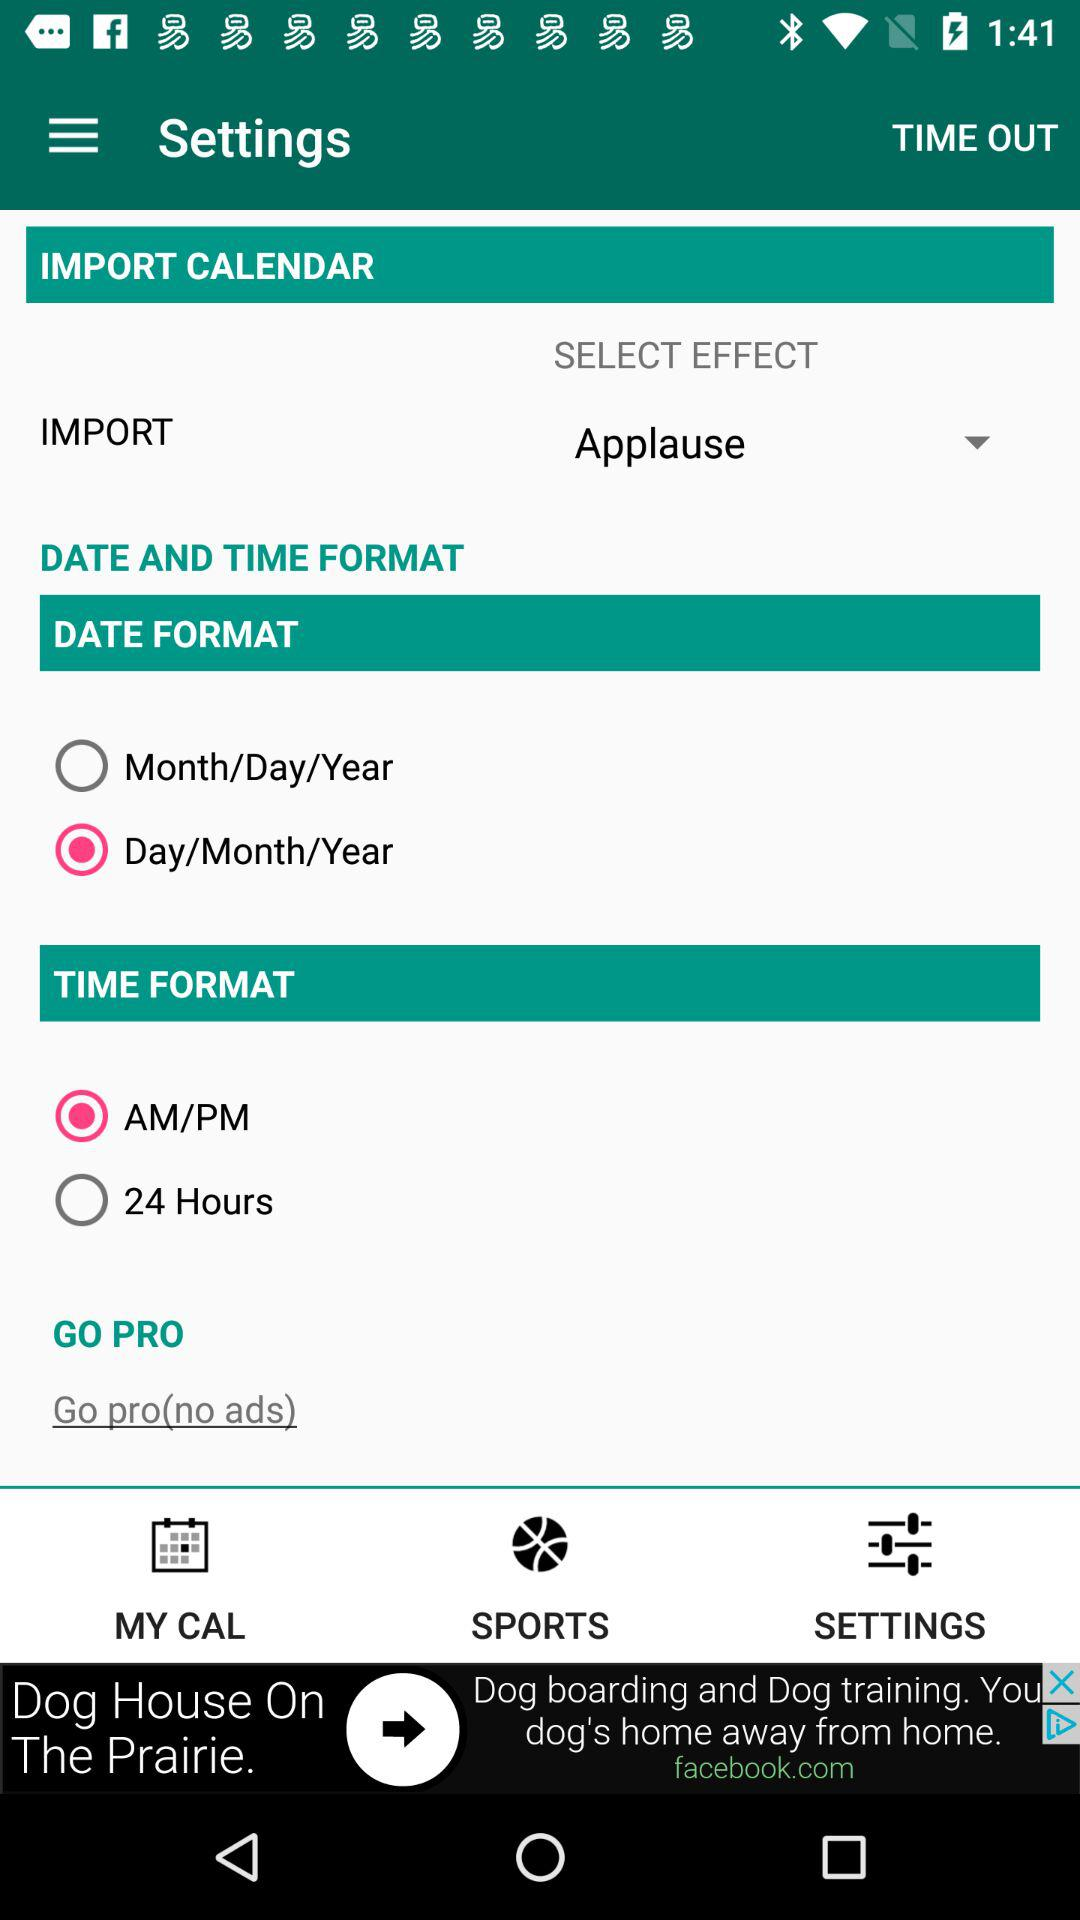What option is selected in "DATE FORMAT"? The selected option is "Day/Month/Year". 